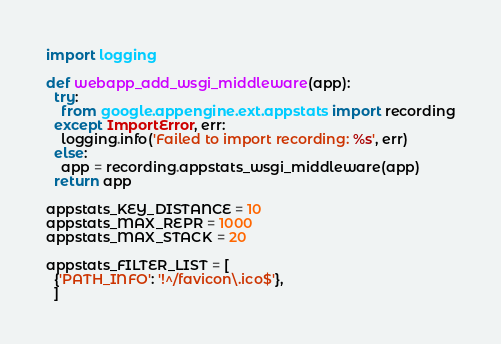Convert code to text. <code><loc_0><loc_0><loc_500><loc_500><_Python_>import logging

def webapp_add_wsgi_middleware(app):
  try:
    from google.appengine.ext.appstats import recording
  except ImportError, err:
    logging.info('Failed to import recording: %s', err)
  else:
    app = recording.appstats_wsgi_middleware(app)
  return app

appstats_KEY_DISTANCE = 10
appstats_MAX_REPR = 1000
appstats_MAX_STACK = 20

appstats_FILTER_LIST = [
  {'PATH_INFO': '!^/favicon\.ico$'},
  ]
</code> 